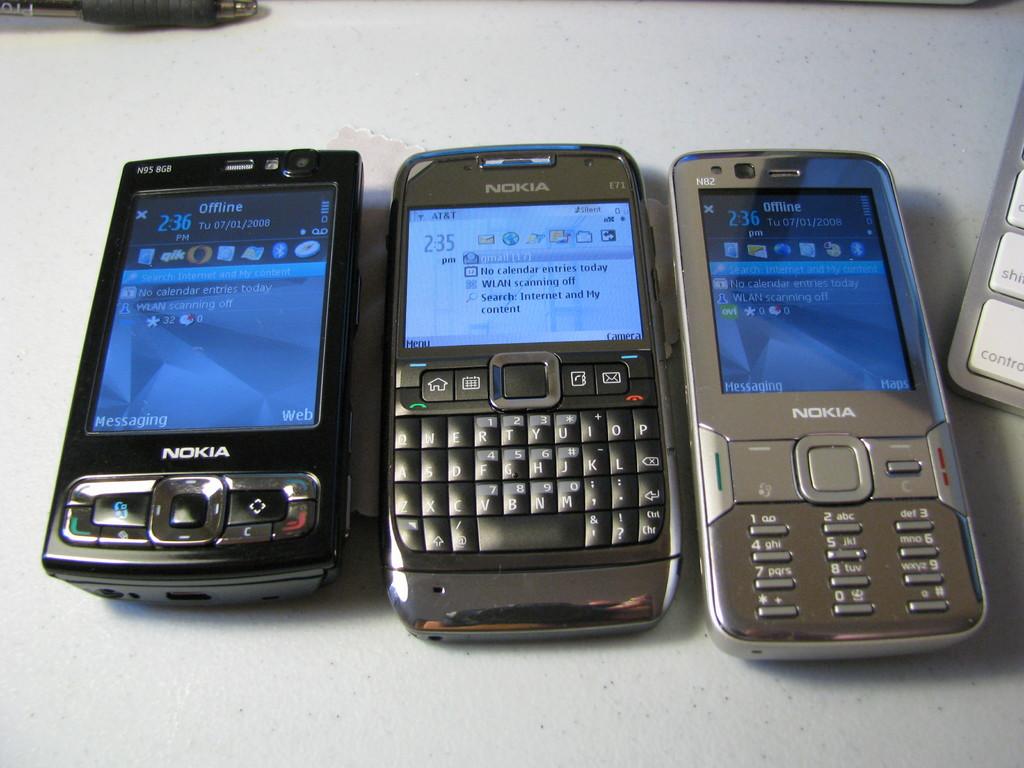What brand are these phones?
Offer a terse response. Nokia. What time is it on the middle phone?
Your answer should be compact. 2:35. 